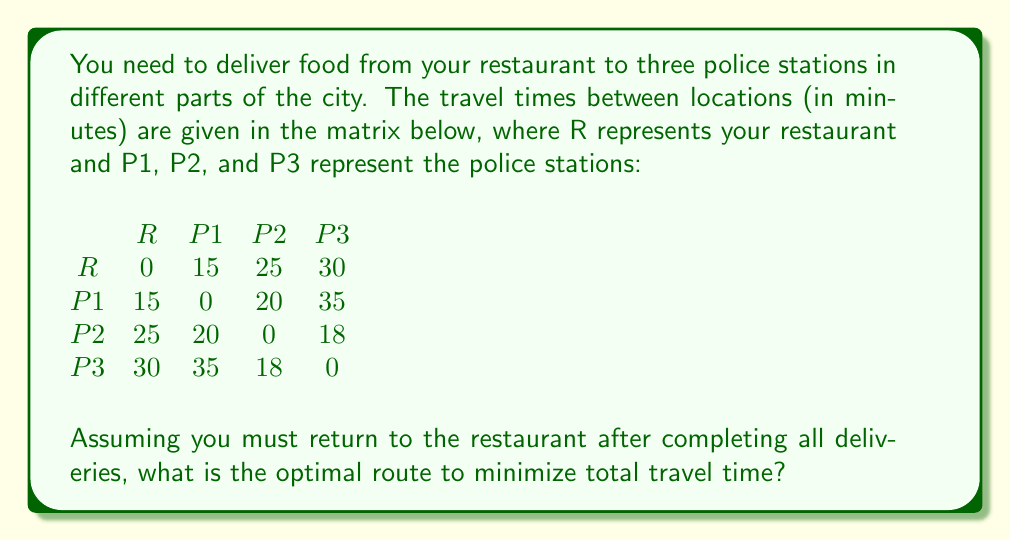Solve this math problem. To solve this problem, we need to find the shortest Hamiltonian cycle, which is known as the Traveling Salesman Problem (TSP). Given the small number of locations, we can use the brute force method to evaluate all possible routes.

Possible routes (starting and ending at R):
1. R -> P1 -> P2 -> P3 -> R
2. R -> P1 -> P3 -> P2 -> R
3. R -> P2 -> P1 -> P3 -> R
4. R -> P2 -> P3 -> P1 -> R
5. R -> P3 -> P1 -> P2 -> R
6. R -> P3 -> P2 -> P1 -> R

Let's calculate the total time for each route:

1. R -> P1 -> P2 -> P3 -> R
   $15 + 20 + 18 + 30 = 83$ minutes

2. R -> P1 -> P3 -> P2 -> R
   $15 + 35 + 18 + 25 = 93$ minutes

3. R -> P2 -> P1 -> P3 -> R
   $25 + 20 + 35 + 30 = 110$ minutes

4. R -> P2 -> P3 -> P1 -> R
   $25 + 18 + 35 + 15 = 93$ minutes

5. R -> P3 -> P1 -> P2 -> R
   $30 + 35 + 20 + 25 = 110$ minutes

6. R -> P3 -> P2 -> P1 -> R
   $30 + 18 + 20 + 15 = 83$ minutes

The optimal routes are 1 and 6, both with a total travel time of 83 minutes.
Answer: The optimal routes are R -> P1 -> P2 -> P3 -> R or R -> P3 -> P2 -> P1 -> R, both with a total travel time of 83 minutes. 